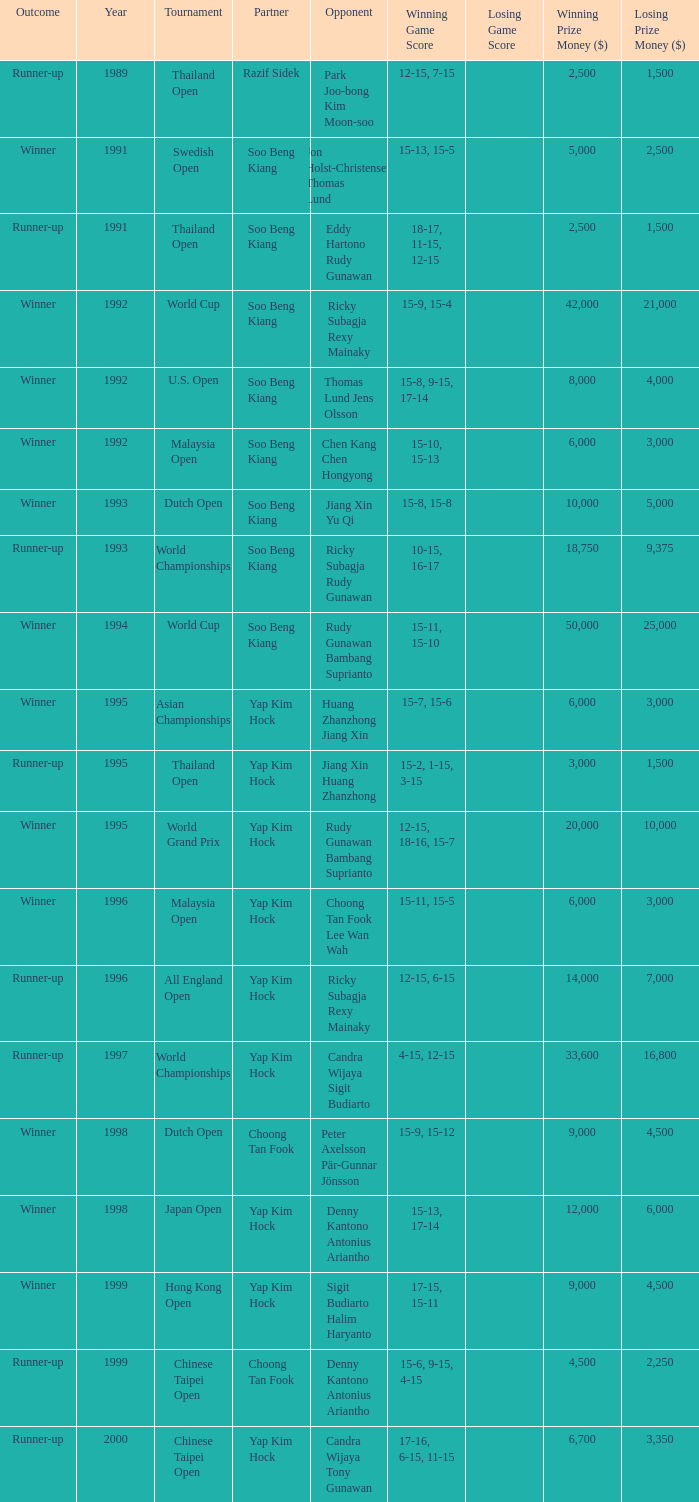Which opponent played in the Chinese Taipei Open in 2000? Candra Wijaya Tony Gunawan. 